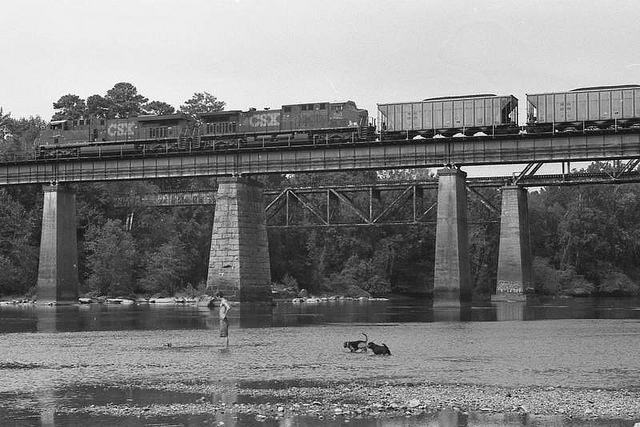How does the presence of the train bridge affect the natural environment shown in the picture? The train bridge, by spanning over the river, can affect the natural environment by altering the flow and ecosystem underneath. It's crucial for such structures to be designed considering their environmental impact, minimizing disruption to aquatic life and maintaining water quality. Are there measures in place to mitigate these environmental impacts? Many regions implement environmental protection measures such as including designs that allow for water and wildlife passage, using eco-friendly materials, or periodic assessments to ensure environmental health around the bridge areas. 